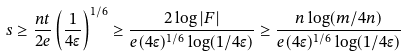<formula> <loc_0><loc_0><loc_500><loc_500>s \geq \frac { n t } { 2 e } \left ( \frac { 1 } { 4 \epsilon } \right ) ^ { 1 / 6 } \geq \frac { 2 \log | F | } { e ( 4 \epsilon ) ^ { 1 / 6 } \log ( 1 / 4 \epsilon ) } \geq \frac { n \log ( m / 4 n ) } { e ( 4 \epsilon ) ^ { 1 / 6 } \log ( 1 / 4 \epsilon ) }</formula> 